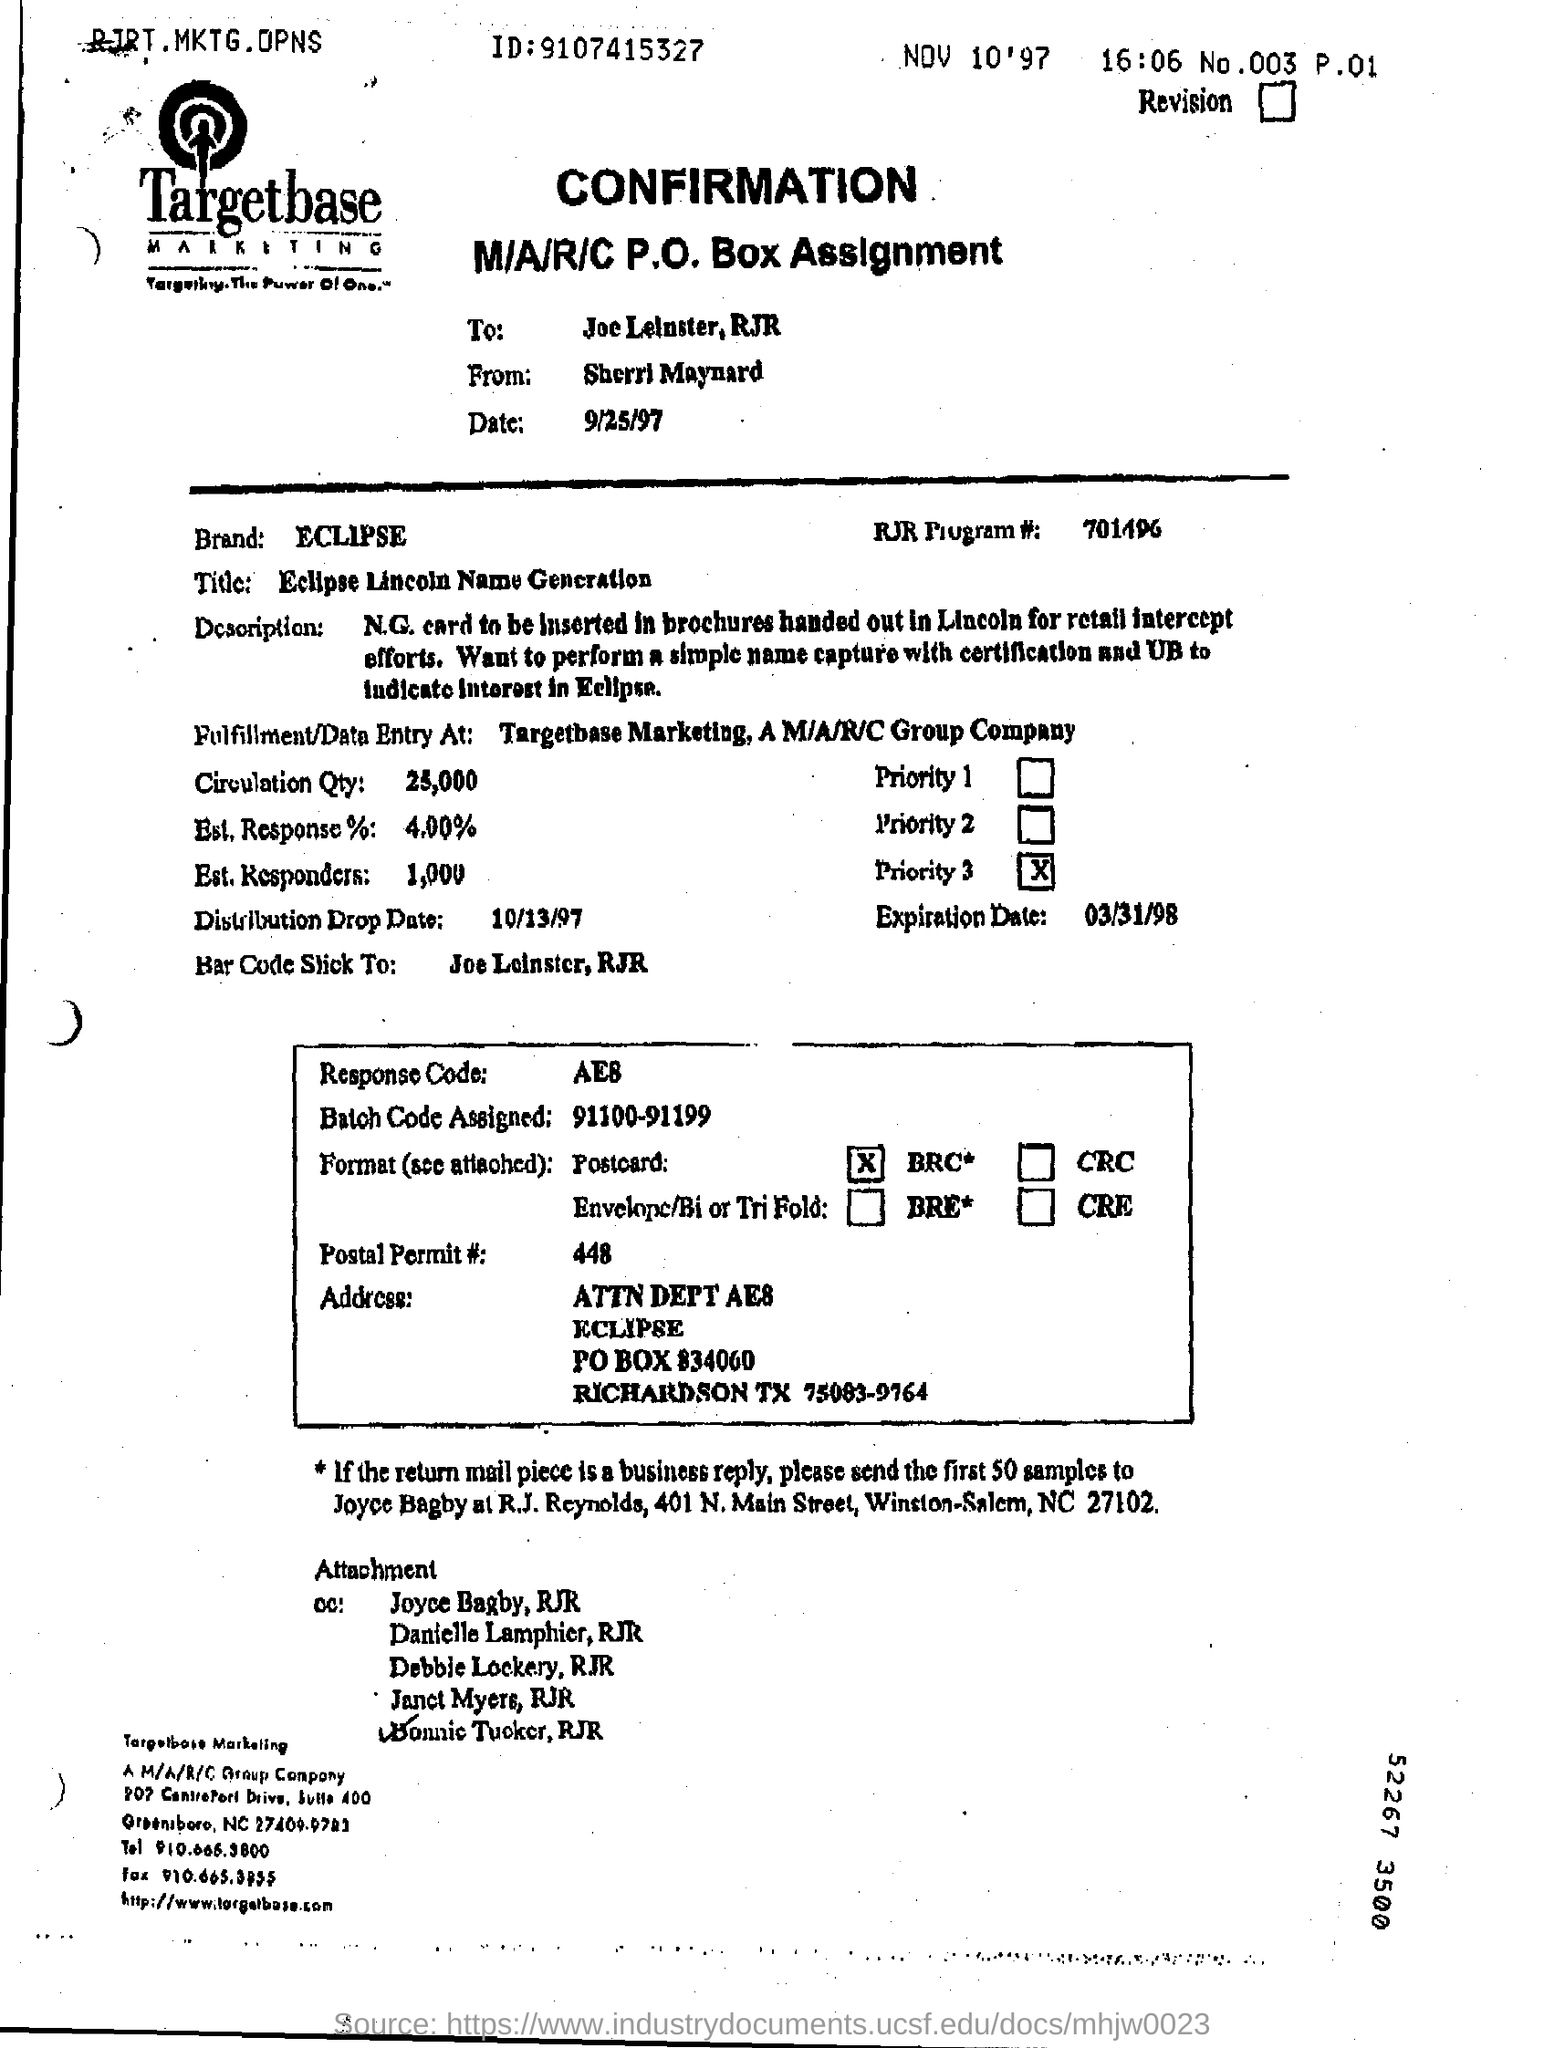To whom is this document addressed?
Your answer should be compact. Joe Leinster. Who is the sender of this confirmation form?
Give a very brief answer. Sherri Maynard. What is the RJR Program # number?
Provide a succinct answer. 701496. 